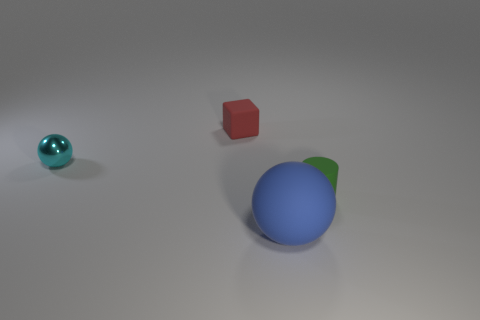Add 2 brown matte blocks. How many objects exist? 6 Subtract all cylinders. How many objects are left? 3 Add 4 big purple things. How many big purple things exist? 4 Subtract 0 green cubes. How many objects are left? 4 Subtract all cyan objects. Subtract all cyan balls. How many objects are left? 2 Add 2 cylinders. How many cylinders are left? 3 